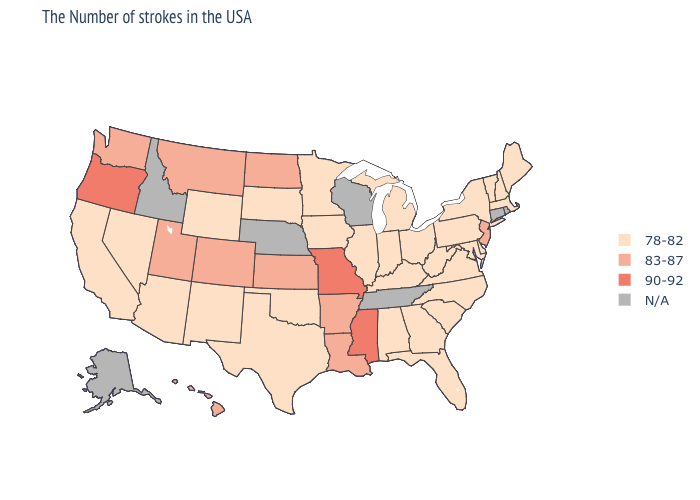Name the states that have a value in the range N/A?
Give a very brief answer. Rhode Island, Connecticut, Tennessee, Wisconsin, Nebraska, Idaho, Alaska. Which states have the highest value in the USA?
Answer briefly. Mississippi, Missouri, Oregon. Which states have the highest value in the USA?
Keep it brief. Mississippi, Missouri, Oregon. Among the states that border Alabama , which have the highest value?
Concise answer only. Mississippi. Among the states that border Pennsylvania , does Maryland have the highest value?
Concise answer only. No. Which states have the highest value in the USA?
Keep it brief. Mississippi, Missouri, Oregon. What is the value of Maine?
Short answer required. 78-82. Name the states that have a value in the range 90-92?
Write a very short answer. Mississippi, Missouri, Oregon. Among the states that border Virginia , which have the highest value?
Answer briefly. Maryland, North Carolina, West Virginia, Kentucky. What is the value of Oregon?
Keep it brief. 90-92. Among the states that border Alabama , does Florida have the highest value?
Write a very short answer. No. Does the map have missing data?
Short answer required. Yes. Name the states that have a value in the range 83-87?
Short answer required. New Jersey, Louisiana, Arkansas, Kansas, North Dakota, Colorado, Utah, Montana, Washington, Hawaii. Among the states that border Colorado , does Arizona have the highest value?
Concise answer only. No. Name the states that have a value in the range 78-82?
Answer briefly. Maine, Massachusetts, New Hampshire, Vermont, New York, Delaware, Maryland, Pennsylvania, Virginia, North Carolina, South Carolina, West Virginia, Ohio, Florida, Georgia, Michigan, Kentucky, Indiana, Alabama, Illinois, Minnesota, Iowa, Oklahoma, Texas, South Dakota, Wyoming, New Mexico, Arizona, Nevada, California. 